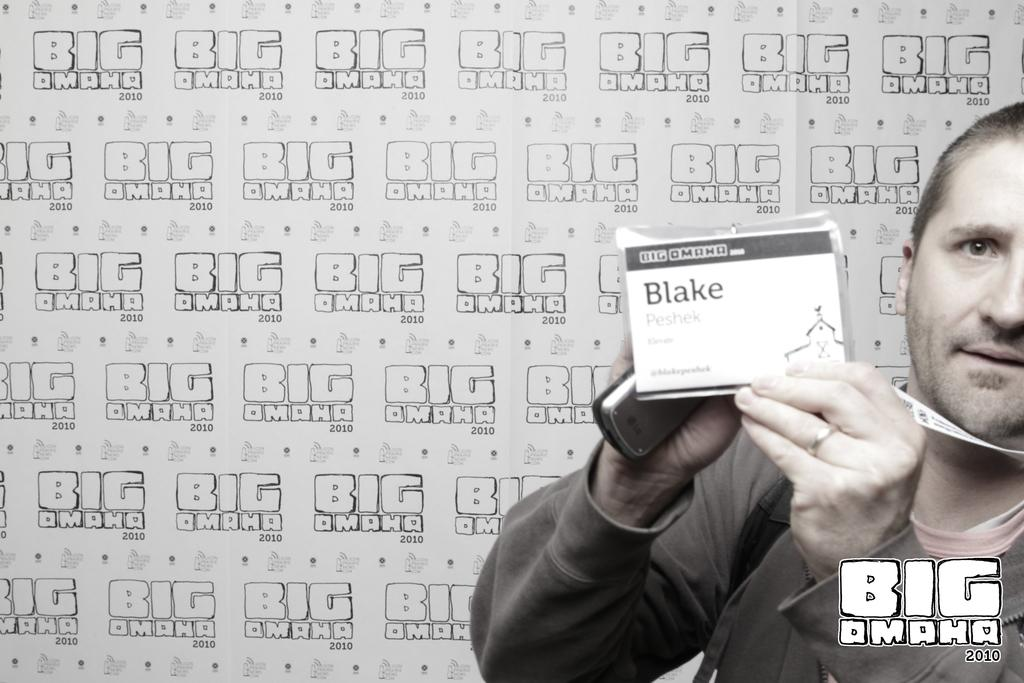Who is present in the image? There is a person in the image. What is the person holding in the image? The person is holding a mobile and an identification card. What can be seen in the background of the image? There is a banner in the background of the image. What is written on the banner? There is text written on the banner. How many chairs are visible in the image? There are no chairs visible in the image. What type of cake is being served at the event depicted in the image? There is no cake present in the image, and no event is depicted. 